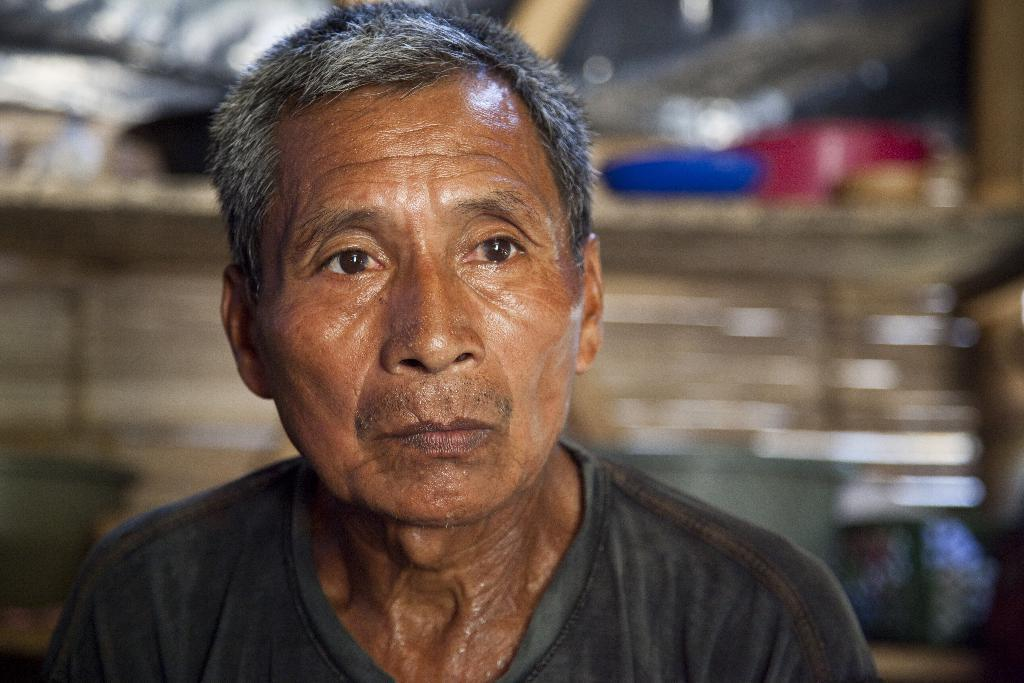What is the main subject of the image? There is a person in the image. Can you describe the background of the image? The background of the image is blurred. Are there any giants visible in the image? There are no giants present in the image. What type of attraction is the person visiting in the image? The provided facts do not mention any attraction, so it cannot be determined from the image. 